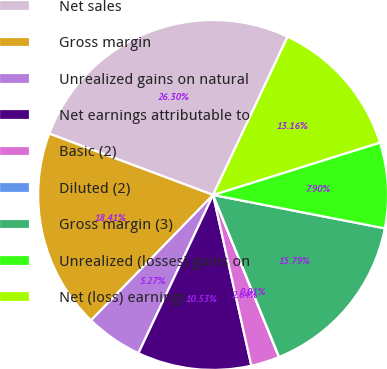Convert chart to OTSL. <chart><loc_0><loc_0><loc_500><loc_500><pie_chart><fcel>Net sales<fcel>Gross margin<fcel>Unrealized gains on natural<fcel>Net earnings attributable to<fcel>Basic (2)<fcel>Diluted (2)<fcel>Gross margin (3)<fcel>Unrealized (losses) gains on<fcel>Net (loss) earnings<nl><fcel>26.31%<fcel>18.42%<fcel>5.27%<fcel>10.53%<fcel>2.64%<fcel>0.01%<fcel>15.79%<fcel>7.9%<fcel>13.16%<nl></chart> 